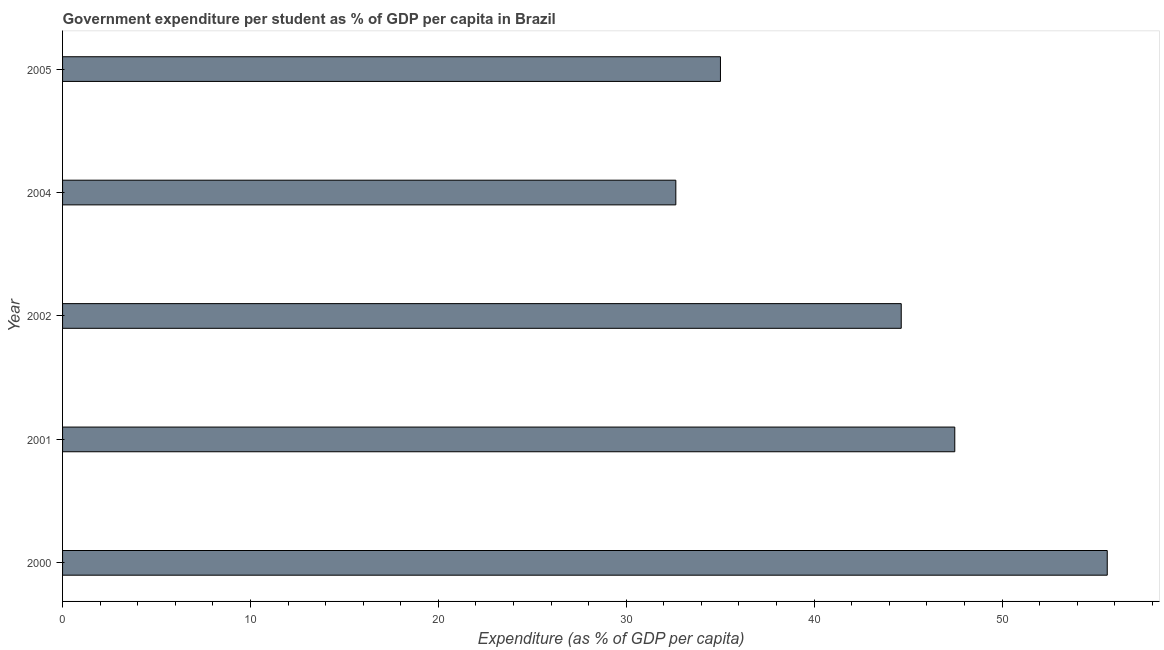Does the graph contain any zero values?
Keep it short and to the point. No. What is the title of the graph?
Give a very brief answer. Government expenditure per student as % of GDP per capita in Brazil. What is the label or title of the X-axis?
Offer a terse response. Expenditure (as % of GDP per capita). What is the label or title of the Y-axis?
Keep it short and to the point. Year. What is the government expenditure per student in 2004?
Provide a succinct answer. 32.64. Across all years, what is the maximum government expenditure per student?
Your response must be concise. 55.6. Across all years, what is the minimum government expenditure per student?
Give a very brief answer. 32.64. In which year was the government expenditure per student maximum?
Make the answer very short. 2000. What is the sum of the government expenditure per student?
Provide a succinct answer. 215.37. What is the difference between the government expenditure per student in 2001 and 2002?
Your answer should be very brief. 2.85. What is the average government expenditure per student per year?
Your response must be concise. 43.07. What is the median government expenditure per student?
Ensure brevity in your answer.  44.63. What is the ratio of the government expenditure per student in 2002 to that in 2005?
Provide a succinct answer. 1.27. Is the government expenditure per student in 2001 less than that in 2004?
Offer a very short reply. No. Is the difference between the government expenditure per student in 2000 and 2002 greater than the difference between any two years?
Offer a terse response. No. What is the difference between the highest and the second highest government expenditure per student?
Ensure brevity in your answer.  8.12. Is the sum of the government expenditure per student in 2001 and 2004 greater than the maximum government expenditure per student across all years?
Ensure brevity in your answer.  Yes. What is the difference between the highest and the lowest government expenditure per student?
Keep it short and to the point. 22.96. How many years are there in the graph?
Your answer should be compact. 5. What is the difference between two consecutive major ticks on the X-axis?
Make the answer very short. 10. What is the Expenditure (as % of GDP per capita) of 2000?
Ensure brevity in your answer.  55.6. What is the Expenditure (as % of GDP per capita) in 2001?
Provide a short and direct response. 47.48. What is the Expenditure (as % of GDP per capita) in 2002?
Ensure brevity in your answer.  44.63. What is the Expenditure (as % of GDP per capita) of 2004?
Your answer should be very brief. 32.64. What is the Expenditure (as % of GDP per capita) of 2005?
Offer a terse response. 35.01. What is the difference between the Expenditure (as % of GDP per capita) in 2000 and 2001?
Offer a terse response. 8.11. What is the difference between the Expenditure (as % of GDP per capita) in 2000 and 2002?
Make the answer very short. 10.96. What is the difference between the Expenditure (as % of GDP per capita) in 2000 and 2004?
Your answer should be compact. 22.96. What is the difference between the Expenditure (as % of GDP per capita) in 2000 and 2005?
Provide a succinct answer. 20.59. What is the difference between the Expenditure (as % of GDP per capita) in 2001 and 2002?
Your answer should be very brief. 2.85. What is the difference between the Expenditure (as % of GDP per capita) in 2001 and 2004?
Offer a very short reply. 14.85. What is the difference between the Expenditure (as % of GDP per capita) in 2001 and 2005?
Provide a short and direct response. 12.47. What is the difference between the Expenditure (as % of GDP per capita) in 2002 and 2004?
Offer a very short reply. 12. What is the difference between the Expenditure (as % of GDP per capita) in 2002 and 2005?
Offer a very short reply. 9.62. What is the difference between the Expenditure (as % of GDP per capita) in 2004 and 2005?
Provide a short and direct response. -2.38. What is the ratio of the Expenditure (as % of GDP per capita) in 2000 to that in 2001?
Provide a succinct answer. 1.17. What is the ratio of the Expenditure (as % of GDP per capita) in 2000 to that in 2002?
Keep it short and to the point. 1.25. What is the ratio of the Expenditure (as % of GDP per capita) in 2000 to that in 2004?
Provide a succinct answer. 1.7. What is the ratio of the Expenditure (as % of GDP per capita) in 2000 to that in 2005?
Keep it short and to the point. 1.59. What is the ratio of the Expenditure (as % of GDP per capita) in 2001 to that in 2002?
Your response must be concise. 1.06. What is the ratio of the Expenditure (as % of GDP per capita) in 2001 to that in 2004?
Keep it short and to the point. 1.46. What is the ratio of the Expenditure (as % of GDP per capita) in 2001 to that in 2005?
Ensure brevity in your answer.  1.36. What is the ratio of the Expenditure (as % of GDP per capita) in 2002 to that in 2004?
Your answer should be compact. 1.37. What is the ratio of the Expenditure (as % of GDP per capita) in 2002 to that in 2005?
Ensure brevity in your answer.  1.27. What is the ratio of the Expenditure (as % of GDP per capita) in 2004 to that in 2005?
Your answer should be very brief. 0.93. 